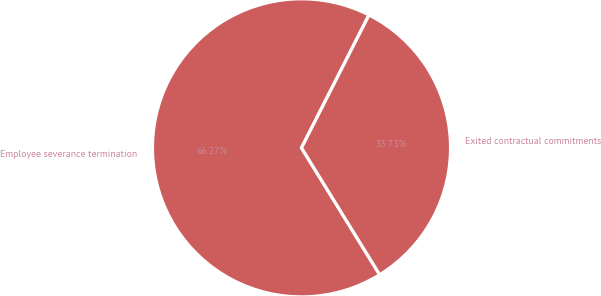Convert chart to OTSL. <chart><loc_0><loc_0><loc_500><loc_500><pie_chart><fcel>Employee severance termination<fcel>Exited contractual commitments<nl><fcel>66.27%<fcel>33.73%<nl></chart> 